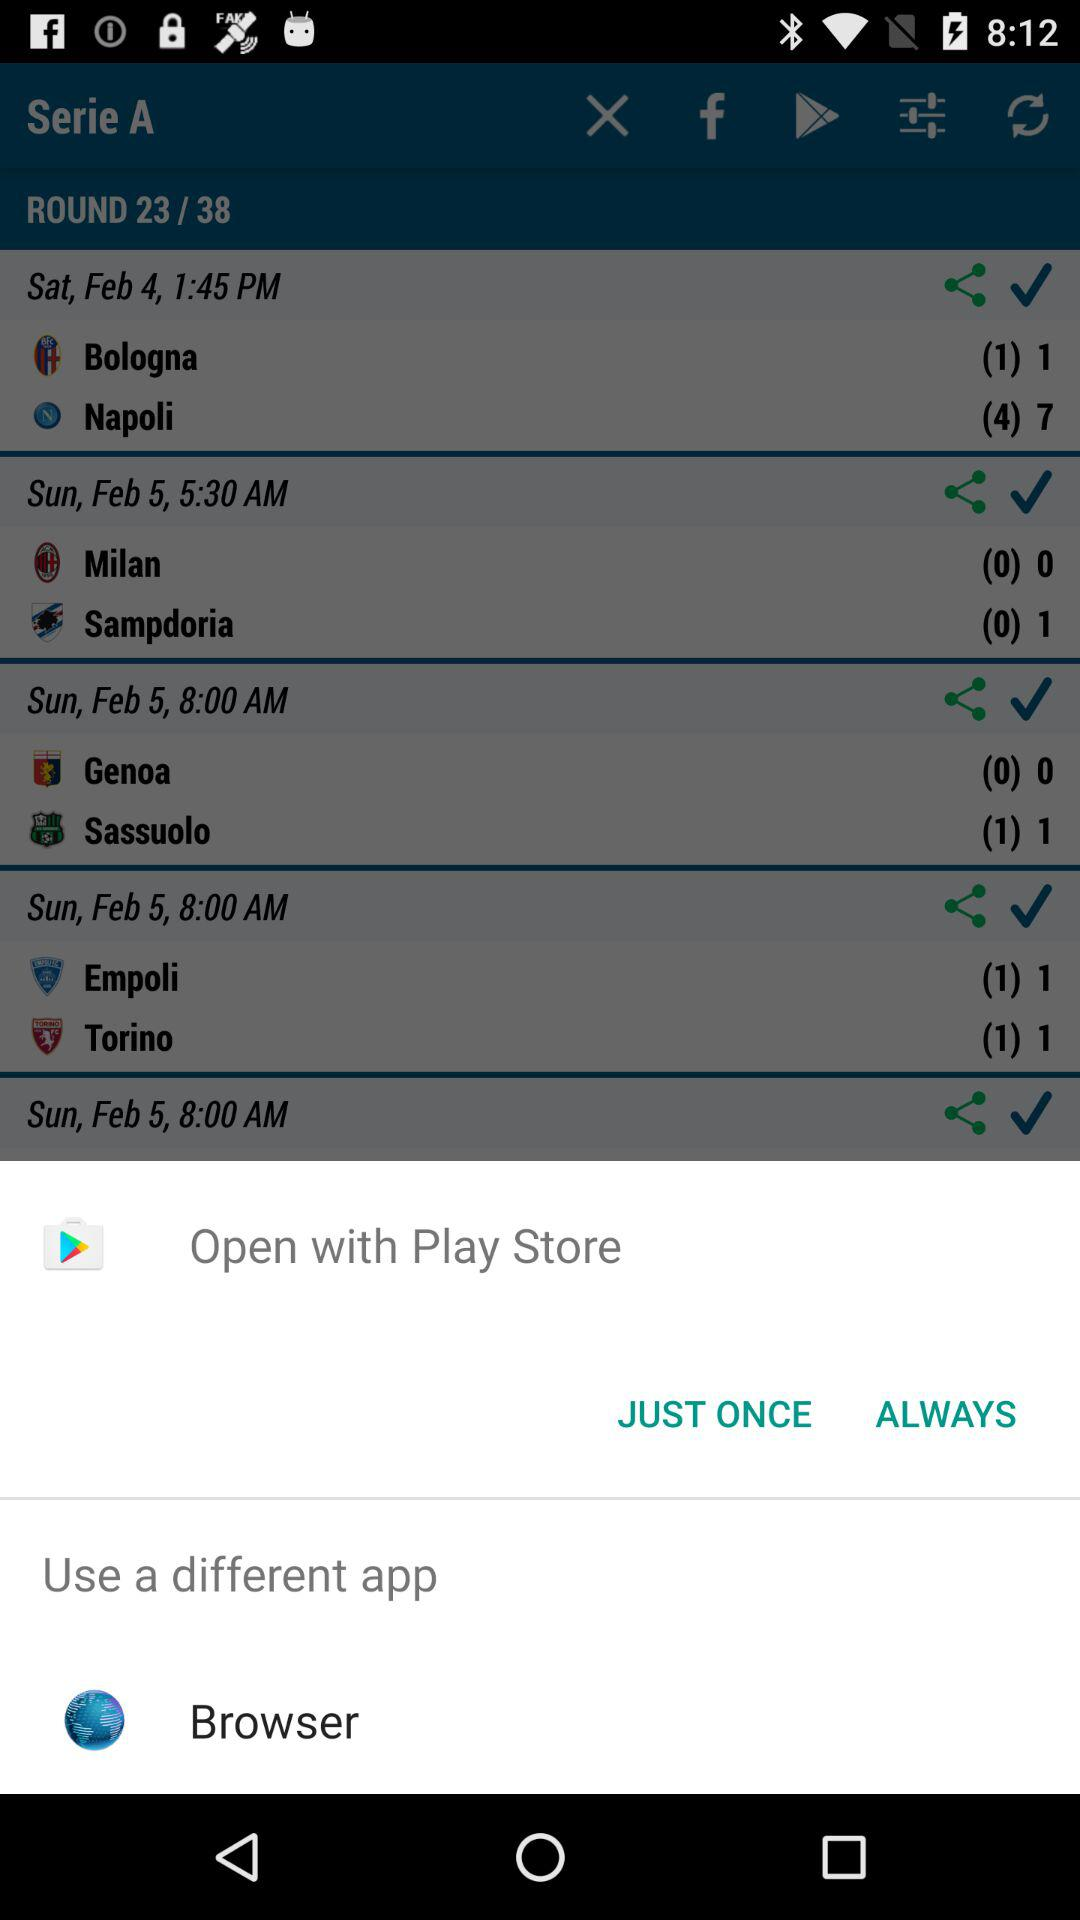Which options are given for opening the content? The options that are given for opening the content are "Play Store" and "Browser". 